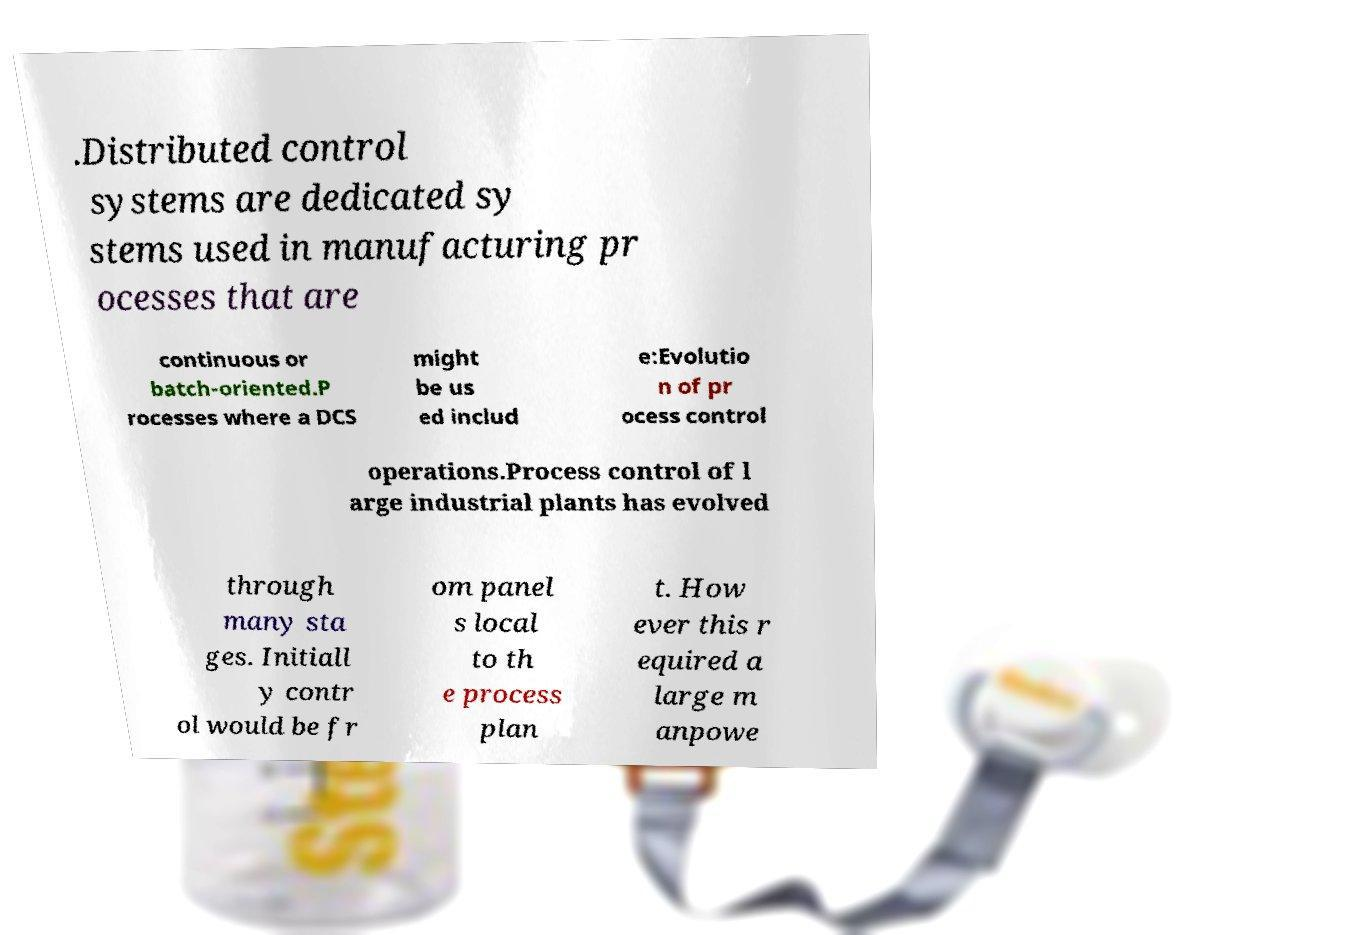Can you read and provide the text displayed in the image?This photo seems to have some interesting text. Can you extract and type it out for me? .Distributed control systems are dedicated sy stems used in manufacturing pr ocesses that are continuous or batch-oriented.P rocesses where a DCS might be us ed includ e:Evolutio n of pr ocess control operations.Process control of l arge industrial plants has evolved through many sta ges. Initiall y contr ol would be fr om panel s local to th e process plan t. How ever this r equired a large m anpowe 